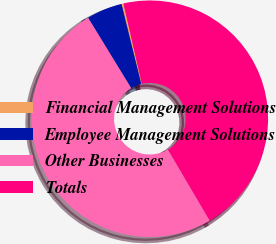<chart> <loc_0><loc_0><loc_500><loc_500><pie_chart><fcel>Financial Management Solutions<fcel>Employee Management Solutions<fcel>Other Businesses<fcel>Totals<nl><fcel>0.28%<fcel>4.88%<fcel>49.72%<fcel>45.12%<nl></chart> 